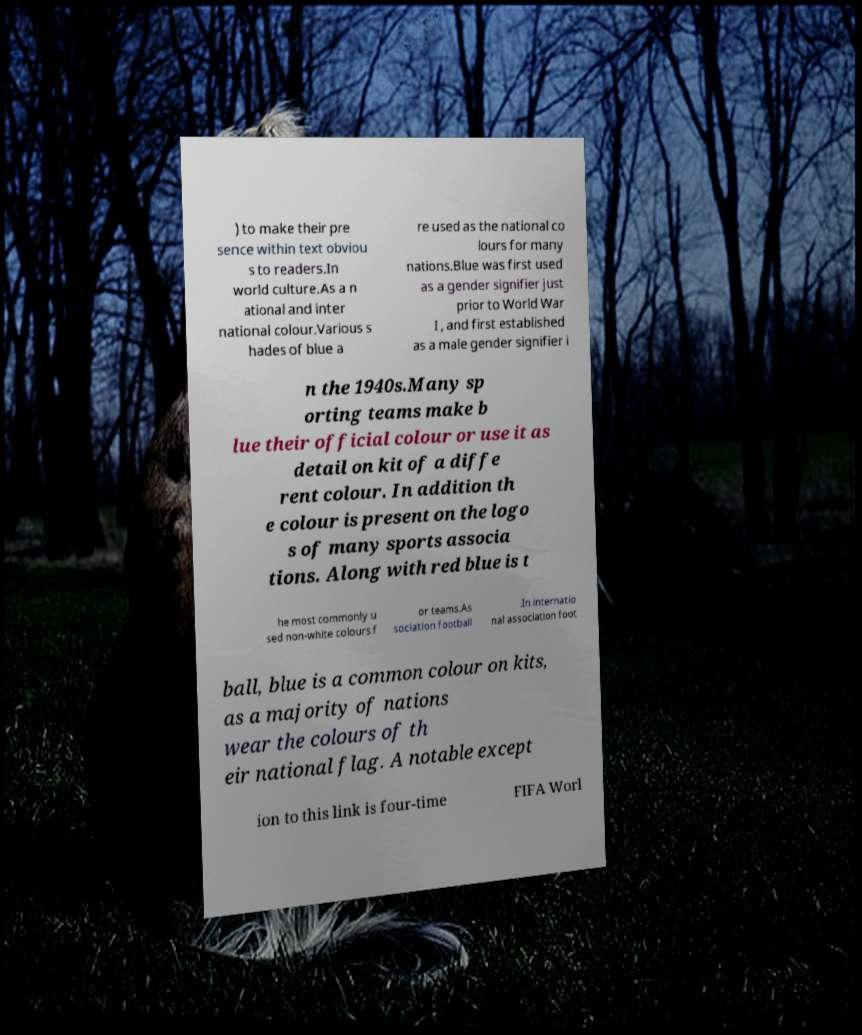Can you accurately transcribe the text from the provided image for me? ) to make their pre sence within text obviou s to readers.In world culture.As a n ational and inter national colour.Various s hades of blue a re used as the national co lours for many nations.Blue was first used as a gender signifier just prior to World War I , and first established as a male gender signifier i n the 1940s.Many sp orting teams make b lue their official colour or use it as detail on kit of a diffe rent colour. In addition th e colour is present on the logo s of many sports associa tions. Along with red blue is t he most commonly u sed non-white colours f or teams.As sociation football .In internatio nal association foot ball, blue is a common colour on kits, as a majority of nations wear the colours of th eir national flag. A notable except ion to this link is four-time FIFA Worl 